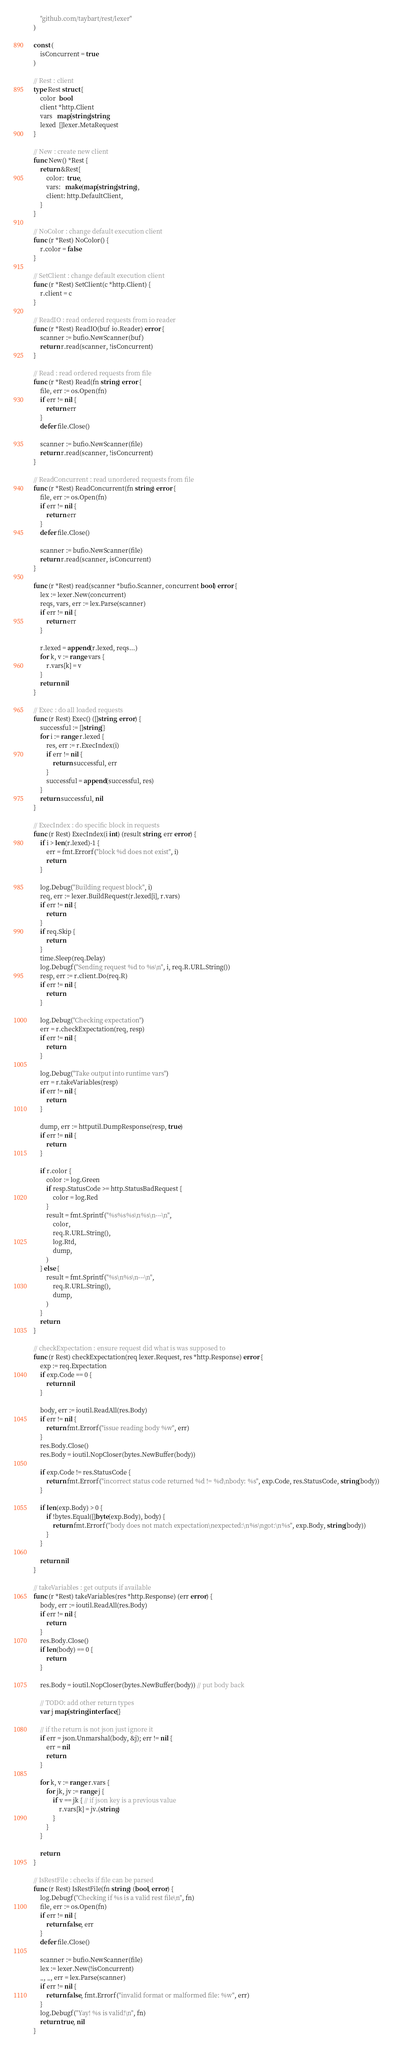Convert code to text. <code><loc_0><loc_0><loc_500><loc_500><_Go_>	"github.com/taybart/rest/lexer"
)

const (
	isConcurrent = true
)

// Rest : client
type Rest struct {
	color  bool
	client *http.Client
	vars   map[string]string
	lexed  []lexer.MetaRequest
}

// New : create new client
func New() *Rest {
	return &Rest{
		color:  true,
		vars:   make(map[string]string),
		client: http.DefaultClient,
	}
}

// NoColor : change default execution client
func (r *Rest) NoColor() {
	r.color = false
}

// SetClient : change default execution client
func (r *Rest) SetClient(c *http.Client) {
	r.client = c
}

// ReadIO : read ordered requests from io reader
func (r *Rest) ReadIO(buf io.Reader) error {
	scanner := bufio.NewScanner(buf)
	return r.read(scanner, !isConcurrent)
}

// Read : read ordered requests from file
func (r *Rest) Read(fn string) error {
	file, err := os.Open(fn)
	if err != nil {
		return err
	}
	defer file.Close()

	scanner := bufio.NewScanner(file)
	return r.read(scanner, !isConcurrent)
}

// ReadConcurrent : read unordered requests from file
func (r *Rest) ReadConcurrent(fn string) error {
	file, err := os.Open(fn)
	if err != nil {
		return err
	}
	defer file.Close()

	scanner := bufio.NewScanner(file)
	return r.read(scanner, isConcurrent)
}

func (r *Rest) read(scanner *bufio.Scanner, concurrent bool) error {
	lex := lexer.New(concurrent)
	reqs, vars, err := lex.Parse(scanner)
	if err != nil {
		return err
	}

	r.lexed = append(r.lexed, reqs...)
	for k, v := range vars {
		r.vars[k] = v
	}
	return nil
}

// Exec : do all loaded requests
func (r Rest) Exec() ([]string, error) {
	successful := []string{}
	for i := range r.lexed {
		res, err := r.ExecIndex(i)
		if err != nil {
			return successful, err
		}
		successful = append(successful, res)
	}
	return successful, nil
}

// ExecIndex : do specific block in requests
func (r Rest) ExecIndex(i int) (result string, err error) {
	if i > len(r.lexed)-1 {
		err = fmt.Errorf("block %d does not exist", i)
		return
	}

	log.Debug("Building request block", i)
	req, err := lexer.BuildRequest(r.lexed[i], r.vars)
	if err != nil {
		return
	}
	if req.Skip {
		return
	}
	time.Sleep(req.Delay)
	log.Debugf("Sending request %d to %s\n", i, req.R.URL.String())
	resp, err := r.client.Do(req.R)
	if err != nil {
		return
	}

	log.Debug("Checking expectation")
	err = r.checkExpectation(req, resp)
	if err != nil {
		return
	}

	log.Debug("Take output into runtime vars")
	err = r.takeVariables(resp)
	if err != nil {
		return
	}

	dump, err := httputil.DumpResponse(resp, true)
	if err != nil {
		return
	}

	if r.color {
		color := log.Green
		if resp.StatusCode >= http.StatusBadRequest {
			color = log.Red
		}
		result = fmt.Sprintf("%s%s%s\n%s\n---\n",
			color,
			req.R.URL.String(),
			log.Rtd,
			dump,
		)
	} else {
		result = fmt.Sprintf("%s\n%s\n---\n",
			req.R.URL.String(),
			dump,
		)
	}
	return
}

// checkExpectation : ensure request did what is was supposed to
func (r Rest) checkExpectation(req lexer.Request, res *http.Response) error {
	exp := req.Expectation
	if exp.Code == 0 {
		return nil
	}

	body, err := ioutil.ReadAll(res.Body)
	if err != nil {
		return fmt.Errorf("issue reading body %w", err)
	}
	res.Body.Close()
	res.Body = ioutil.NopCloser(bytes.NewBuffer(body))

	if exp.Code != res.StatusCode {
		return fmt.Errorf("incorrect status code returned %d != %d\nbody: %s", exp.Code, res.StatusCode, string(body))
	}

	if len(exp.Body) > 0 {
		if !bytes.Equal([]byte(exp.Body), body) {
			return fmt.Errorf("body does not match expectation\nexpected:\n%s\ngot:\n%s", exp.Body, string(body))
		}
	}

	return nil
}

// takeVariables : get outputs if available
func (r *Rest) takeVariables(res *http.Response) (err error) {
	body, err := ioutil.ReadAll(res.Body)
	if err != nil {
		return
	}
	res.Body.Close()
	if len(body) == 0 {
		return
	}

	res.Body = ioutil.NopCloser(bytes.NewBuffer(body)) // put body back

	// TODO: add other return types
	var j map[string]interface{}

	// if the return is not json just ignore it
	if err = json.Unmarshal(body, &j); err != nil {
		err = nil
		return
	}

	for k, v := range r.vars {
		for jk, jv := range j {
			if v == jk { // if json key is a previous value
				r.vars[k] = jv.(string)
			}
		}
	}

	return
}

// IsRestFile : checks if file can be parsed
func (r Rest) IsRestFile(fn string) (bool, error) {
	log.Debugf("Checking if %s is a valid rest file\n", fn)
	file, err := os.Open(fn)
	if err != nil {
		return false, err
	}
	defer file.Close()

	scanner := bufio.NewScanner(file)
	lex := lexer.New(!isConcurrent)
	_, _, err = lex.Parse(scanner)
	if err != nil {
		return false, fmt.Errorf("invalid format or malformed file: %w", err)
	}
	log.Debugf("Yay! %s is valid!\n", fn)
	return true, nil
}
</code> 